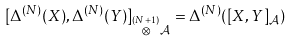<formula> <loc_0><loc_0><loc_500><loc_500>[ \Delta ^ { ( N ) } ( X ) , \Delta ^ { ( N ) } ( Y ) ] _ { \overset { ( N + 1 ) } { \mathcal { \otimes } } \mathcal { A } } = \Delta ^ { ( N ) } ( [ X , Y ] _ { \mathcal { A } } )</formula> 